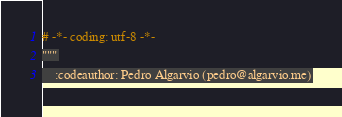<code> <loc_0><loc_0><loc_500><loc_500><_Python_># -*- coding: utf-8 -*-
"""
    :codeauthor: Pedro Algarvio (pedro@algarvio.me)

</code> 